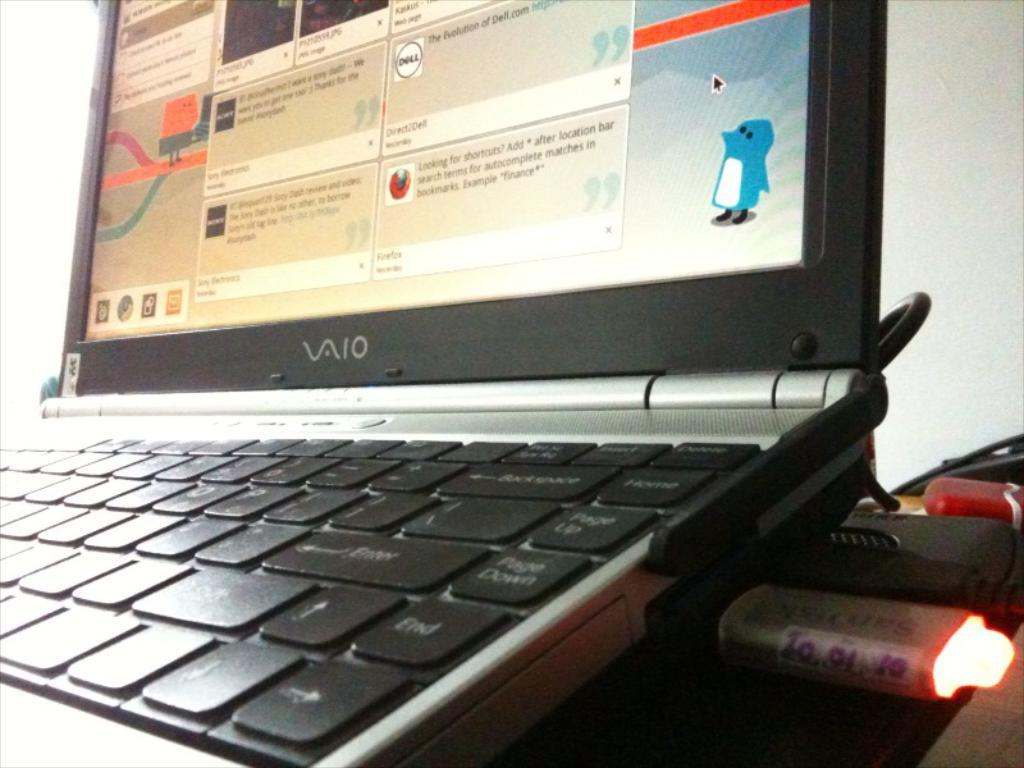Provide a one-sentence caption for the provided image. A VAIO laptop has a picture of a penguin in the lower right corner. 